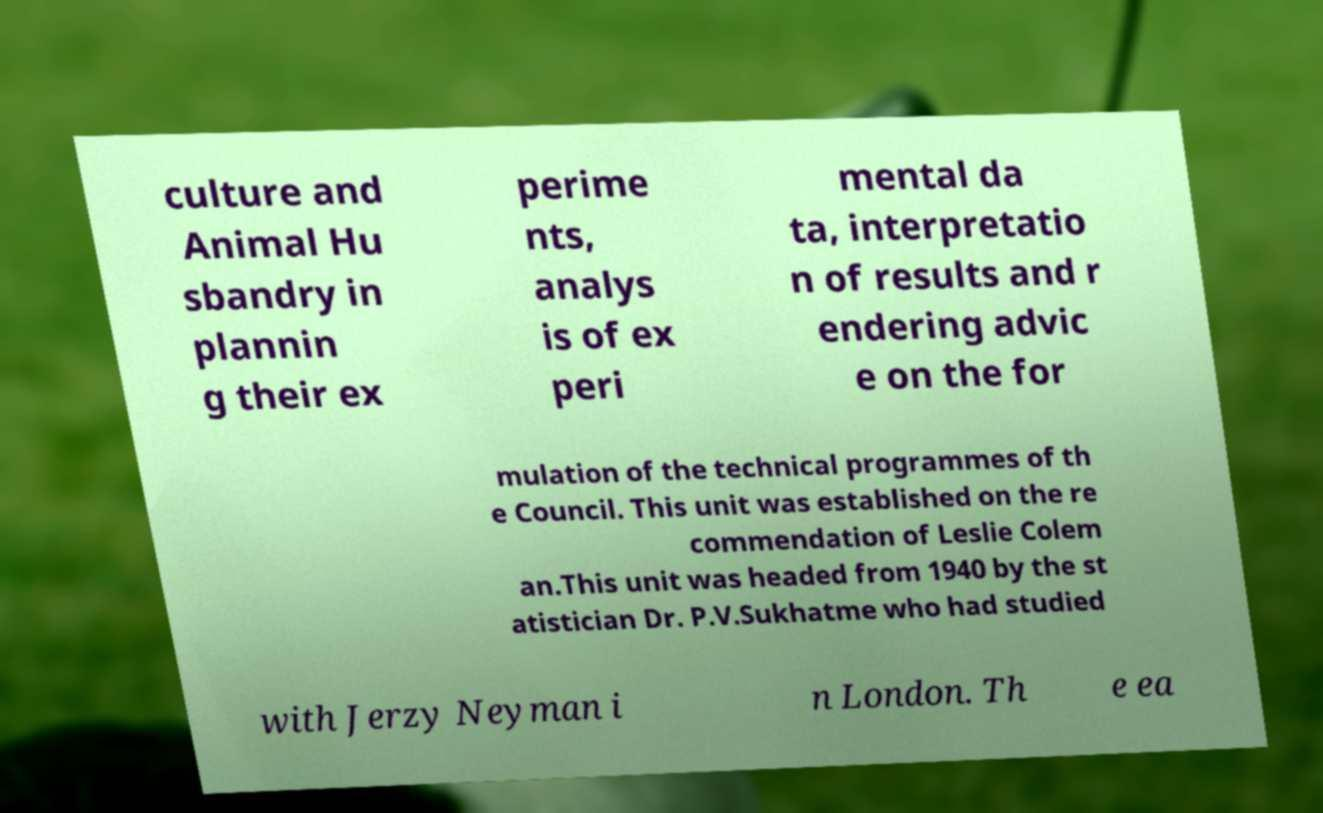Please read and relay the text visible in this image. What does it say? culture and Animal Hu sbandry in plannin g their ex perime nts, analys is of ex peri mental da ta, interpretatio n of results and r endering advic e on the for mulation of the technical programmes of th e Council. This unit was established on the re commendation of Leslie Colem an.This unit was headed from 1940 by the st atistician Dr. P.V.Sukhatme who had studied with Jerzy Neyman i n London. Th e ea 